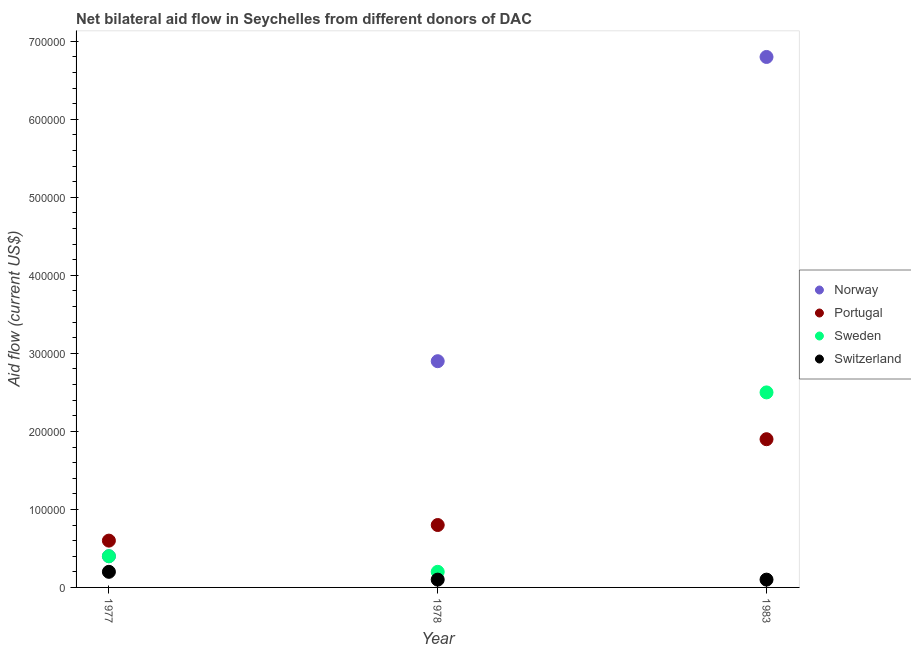How many different coloured dotlines are there?
Make the answer very short. 4. Is the number of dotlines equal to the number of legend labels?
Your answer should be very brief. Yes. What is the amount of aid given by sweden in 1983?
Keep it short and to the point. 2.50e+05. Across all years, what is the maximum amount of aid given by sweden?
Your answer should be compact. 2.50e+05. Across all years, what is the minimum amount of aid given by norway?
Make the answer very short. 4.00e+04. In which year was the amount of aid given by sweden minimum?
Keep it short and to the point. 1978. What is the total amount of aid given by sweden in the graph?
Your response must be concise. 3.10e+05. What is the difference between the amount of aid given by switzerland in 1977 and that in 1983?
Provide a succinct answer. 10000. What is the difference between the amount of aid given by norway in 1978 and the amount of aid given by portugal in 1977?
Provide a succinct answer. 2.30e+05. What is the average amount of aid given by norway per year?
Give a very brief answer. 3.37e+05. In the year 1977, what is the difference between the amount of aid given by norway and amount of aid given by switzerland?
Provide a short and direct response. 2.00e+04. What is the difference between the highest and the lowest amount of aid given by norway?
Offer a terse response. 6.40e+05. Is it the case that in every year, the sum of the amount of aid given by norway and amount of aid given by portugal is greater than the amount of aid given by sweden?
Give a very brief answer. Yes. Does the amount of aid given by norway monotonically increase over the years?
Offer a very short reply. Yes. Is the amount of aid given by norway strictly greater than the amount of aid given by portugal over the years?
Give a very brief answer. No. How many dotlines are there?
Give a very brief answer. 4. How many legend labels are there?
Your answer should be compact. 4. What is the title of the graph?
Provide a succinct answer. Net bilateral aid flow in Seychelles from different donors of DAC. Does "UNAIDS" appear as one of the legend labels in the graph?
Offer a very short reply. No. What is the label or title of the X-axis?
Ensure brevity in your answer.  Year. What is the Aid flow (current US$) of Norway in 1977?
Your response must be concise. 4.00e+04. What is the Aid flow (current US$) of Switzerland in 1977?
Ensure brevity in your answer.  2.00e+04. What is the Aid flow (current US$) in Portugal in 1978?
Make the answer very short. 8.00e+04. What is the Aid flow (current US$) of Sweden in 1978?
Your response must be concise. 2.00e+04. What is the Aid flow (current US$) in Switzerland in 1978?
Keep it short and to the point. 10000. What is the Aid flow (current US$) in Norway in 1983?
Your answer should be very brief. 6.80e+05. What is the Aid flow (current US$) in Sweden in 1983?
Your answer should be very brief. 2.50e+05. What is the Aid flow (current US$) in Switzerland in 1983?
Your answer should be very brief. 10000. Across all years, what is the maximum Aid flow (current US$) of Norway?
Provide a short and direct response. 6.80e+05. Across all years, what is the maximum Aid flow (current US$) of Portugal?
Provide a succinct answer. 1.90e+05. Across all years, what is the maximum Aid flow (current US$) in Switzerland?
Provide a succinct answer. 2.00e+04. Across all years, what is the minimum Aid flow (current US$) of Norway?
Make the answer very short. 4.00e+04. Across all years, what is the minimum Aid flow (current US$) of Portugal?
Your response must be concise. 6.00e+04. Across all years, what is the minimum Aid flow (current US$) of Sweden?
Your answer should be compact. 2.00e+04. Across all years, what is the minimum Aid flow (current US$) of Switzerland?
Keep it short and to the point. 10000. What is the total Aid flow (current US$) in Norway in the graph?
Make the answer very short. 1.01e+06. What is the total Aid flow (current US$) of Portugal in the graph?
Your answer should be compact. 3.30e+05. What is the total Aid flow (current US$) of Switzerland in the graph?
Keep it short and to the point. 4.00e+04. What is the difference between the Aid flow (current US$) in Portugal in 1977 and that in 1978?
Offer a very short reply. -2.00e+04. What is the difference between the Aid flow (current US$) in Sweden in 1977 and that in 1978?
Offer a terse response. 2.00e+04. What is the difference between the Aid flow (current US$) in Norway in 1977 and that in 1983?
Provide a succinct answer. -6.40e+05. What is the difference between the Aid flow (current US$) in Switzerland in 1977 and that in 1983?
Offer a very short reply. 10000. What is the difference between the Aid flow (current US$) of Norway in 1978 and that in 1983?
Give a very brief answer. -3.90e+05. What is the difference between the Aid flow (current US$) of Portugal in 1978 and that in 1983?
Make the answer very short. -1.10e+05. What is the difference between the Aid flow (current US$) of Sweden in 1978 and that in 1983?
Provide a short and direct response. -2.30e+05. What is the difference between the Aid flow (current US$) of Switzerland in 1978 and that in 1983?
Your response must be concise. 0. What is the difference between the Aid flow (current US$) of Norway in 1977 and the Aid flow (current US$) of Portugal in 1978?
Give a very brief answer. -4.00e+04. What is the difference between the Aid flow (current US$) of Norway in 1977 and the Aid flow (current US$) of Sweden in 1983?
Ensure brevity in your answer.  -2.10e+05. What is the difference between the Aid flow (current US$) in Norway in 1977 and the Aid flow (current US$) in Switzerland in 1983?
Provide a short and direct response. 3.00e+04. What is the difference between the Aid flow (current US$) of Portugal in 1977 and the Aid flow (current US$) of Sweden in 1983?
Give a very brief answer. -1.90e+05. What is the difference between the Aid flow (current US$) in Sweden in 1977 and the Aid flow (current US$) in Switzerland in 1983?
Your answer should be very brief. 3.00e+04. What is the difference between the Aid flow (current US$) of Portugal in 1978 and the Aid flow (current US$) of Sweden in 1983?
Ensure brevity in your answer.  -1.70e+05. What is the difference between the Aid flow (current US$) of Portugal in 1978 and the Aid flow (current US$) of Switzerland in 1983?
Ensure brevity in your answer.  7.00e+04. What is the average Aid flow (current US$) of Norway per year?
Your response must be concise. 3.37e+05. What is the average Aid flow (current US$) in Portugal per year?
Provide a succinct answer. 1.10e+05. What is the average Aid flow (current US$) of Sweden per year?
Your answer should be compact. 1.03e+05. What is the average Aid flow (current US$) in Switzerland per year?
Ensure brevity in your answer.  1.33e+04. In the year 1977, what is the difference between the Aid flow (current US$) in Norway and Aid flow (current US$) in Portugal?
Offer a terse response. -2.00e+04. In the year 1977, what is the difference between the Aid flow (current US$) in Norway and Aid flow (current US$) in Switzerland?
Make the answer very short. 2.00e+04. In the year 1977, what is the difference between the Aid flow (current US$) of Portugal and Aid flow (current US$) of Sweden?
Offer a very short reply. 2.00e+04. In the year 1977, what is the difference between the Aid flow (current US$) of Portugal and Aid flow (current US$) of Switzerland?
Make the answer very short. 4.00e+04. In the year 1977, what is the difference between the Aid flow (current US$) of Sweden and Aid flow (current US$) of Switzerland?
Ensure brevity in your answer.  2.00e+04. In the year 1978, what is the difference between the Aid flow (current US$) in Norway and Aid flow (current US$) in Portugal?
Provide a succinct answer. 2.10e+05. In the year 1978, what is the difference between the Aid flow (current US$) in Norway and Aid flow (current US$) in Sweden?
Your answer should be very brief. 2.70e+05. In the year 1978, what is the difference between the Aid flow (current US$) of Norway and Aid flow (current US$) of Switzerland?
Your answer should be compact. 2.80e+05. In the year 1978, what is the difference between the Aid flow (current US$) in Sweden and Aid flow (current US$) in Switzerland?
Make the answer very short. 10000. In the year 1983, what is the difference between the Aid flow (current US$) in Norway and Aid flow (current US$) in Portugal?
Give a very brief answer. 4.90e+05. In the year 1983, what is the difference between the Aid flow (current US$) in Norway and Aid flow (current US$) in Sweden?
Your response must be concise. 4.30e+05. In the year 1983, what is the difference between the Aid flow (current US$) of Norway and Aid flow (current US$) of Switzerland?
Offer a very short reply. 6.70e+05. In the year 1983, what is the difference between the Aid flow (current US$) of Portugal and Aid flow (current US$) of Sweden?
Your answer should be compact. -6.00e+04. What is the ratio of the Aid flow (current US$) of Norway in 1977 to that in 1978?
Your answer should be compact. 0.14. What is the ratio of the Aid flow (current US$) of Portugal in 1977 to that in 1978?
Provide a succinct answer. 0.75. What is the ratio of the Aid flow (current US$) in Norway in 1977 to that in 1983?
Your response must be concise. 0.06. What is the ratio of the Aid flow (current US$) in Portugal in 1977 to that in 1983?
Your response must be concise. 0.32. What is the ratio of the Aid flow (current US$) in Sweden in 1977 to that in 1983?
Keep it short and to the point. 0.16. What is the ratio of the Aid flow (current US$) in Norway in 1978 to that in 1983?
Your response must be concise. 0.43. What is the ratio of the Aid flow (current US$) of Portugal in 1978 to that in 1983?
Your answer should be very brief. 0.42. What is the ratio of the Aid flow (current US$) in Sweden in 1978 to that in 1983?
Your response must be concise. 0.08. What is the difference between the highest and the second highest Aid flow (current US$) in Norway?
Your response must be concise. 3.90e+05. What is the difference between the highest and the lowest Aid flow (current US$) of Norway?
Provide a short and direct response. 6.40e+05. 